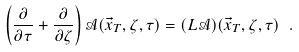<formula> <loc_0><loc_0><loc_500><loc_500>\left ( \frac { \partial } { \partial \tau } + \frac { \partial } { \partial \zeta } \right ) \mathcal { A } ( \vec { x } _ { T } , \zeta , \tau ) = ( L \mathcal { A } ) ( \vec { x } _ { T } , \zeta , \tau ) \ .</formula> 